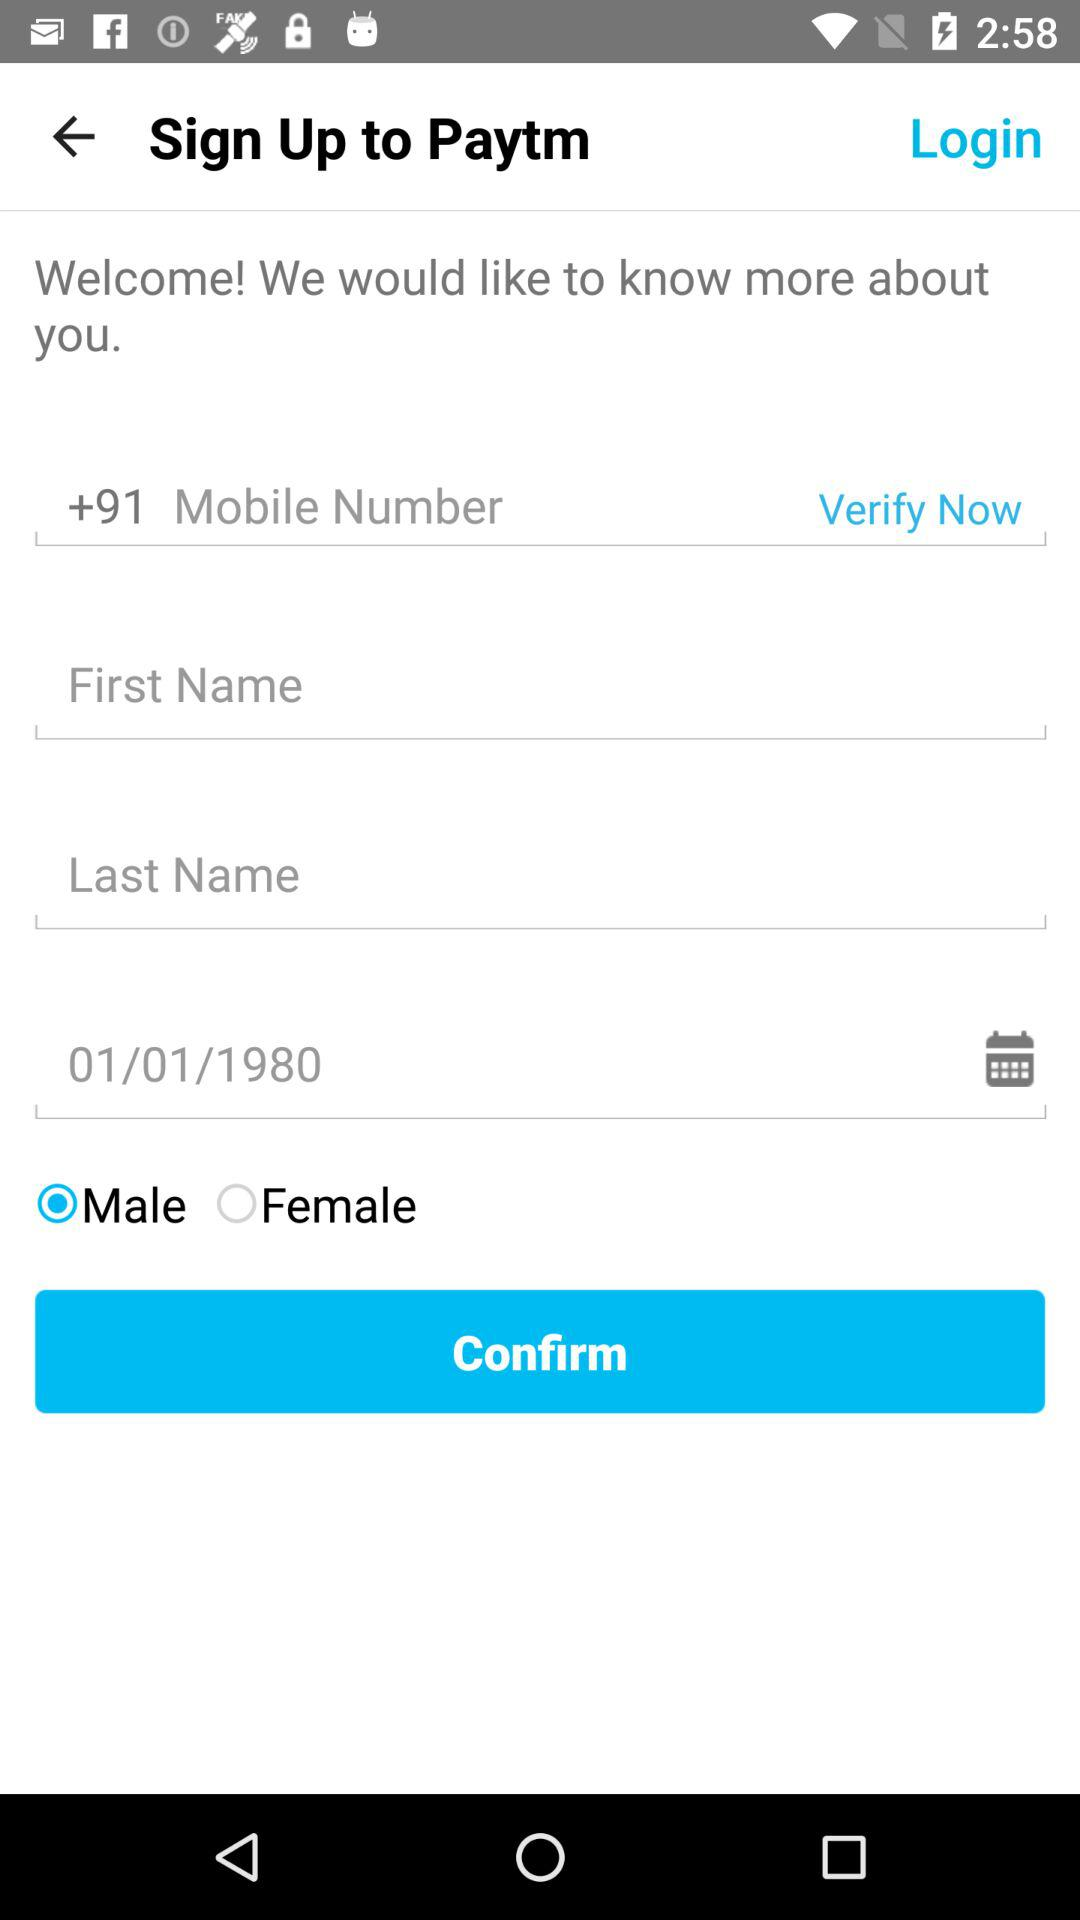What is the date of birth? The date of birth is January 1, 1980. 